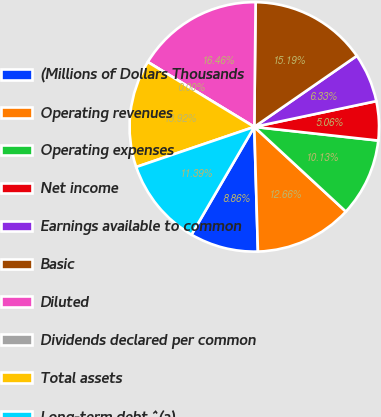Convert chart. <chart><loc_0><loc_0><loc_500><loc_500><pie_chart><fcel>(Millions of Dollars Thousands<fcel>Operating revenues<fcel>Operating expenses<fcel>Net income<fcel>Earnings available to common<fcel>Basic<fcel>Diluted<fcel>Dividends declared per common<fcel>Total assets<fcel>Long-term debt ^(a)<nl><fcel>8.86%<fcel>12.66%<fcel>10.13%<fcel>5.06%<fcel>6.33%<fcel>15.19%<fcel>16.46%<fcel>0.0%<fcel>13.92%<fcel>11.39%<nl></chart> 